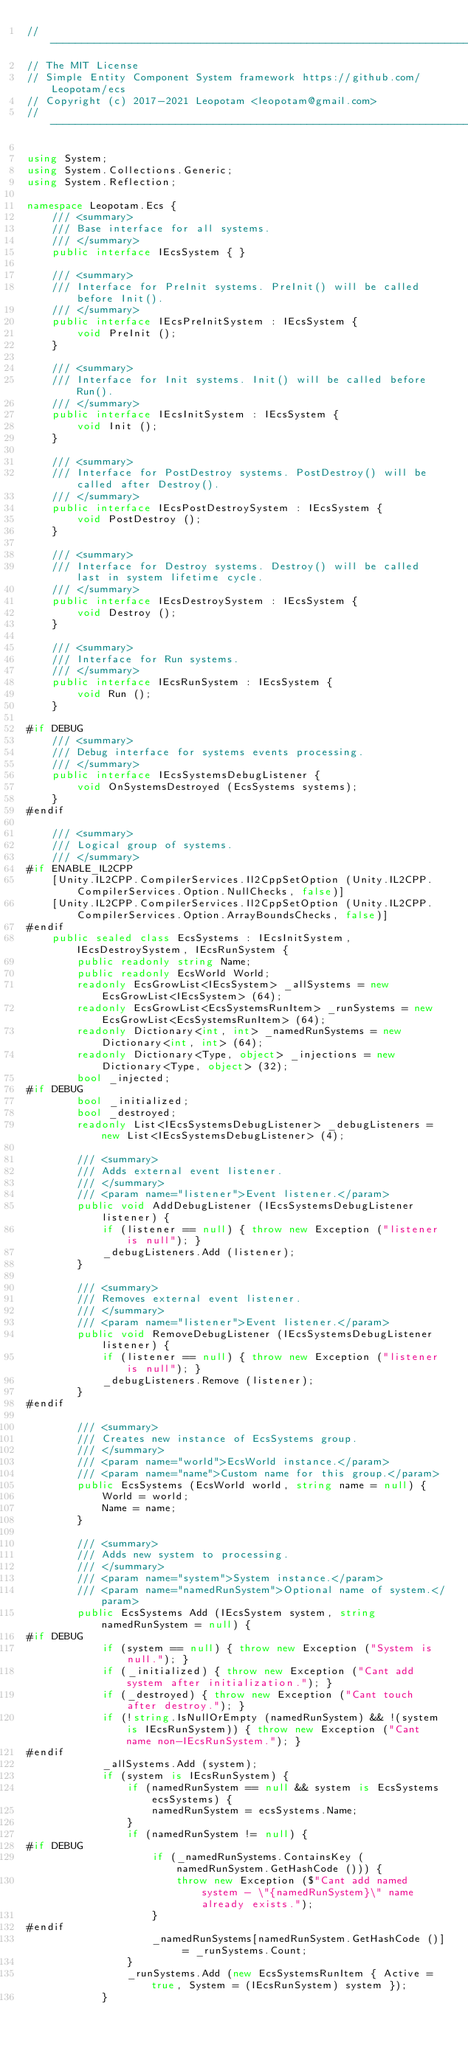Convert code to text. <code><loc_0><loc_0><loc_500><loc_500><_C#_>// ----------------------------------------------------------------------------
// The MIT License
// Simple Entity Component System framework https://github.com/Leopotam/ecs
// Copyright (c) 2017-2021 Leopotam <leopotam@gmail.com>
// ----------------------------------------------------------------------------

using System;
using System.Collections.Generic;
using System.Reflection;

namespace Leopotam.Ecs {
    /// <summary>
    /// Base interface for all systems.
    /// </summary>
    public interface IEcsSystem { }

    /// <summary>
    /// Interface for PreInit systems. PreInit() will be called before Init().
    /// </summary>
    public interface IEcsPreInitSystem : IEcsSystem {
        void PreInit ();
    }

    /// <summary>
    /// Interface for Init systems. Init() will be called before Run().
    /// </summary>
    public interface IEcsInitSystem : IEcsSystem {
        void Init ();
    }

    /// <summary>
    /// Interface for PostDestroy systems. PostDestroy() will be called after Destroy().
    /// </summary>
    public interface IEcsPostDestroySystem : IEcsSystem {
        void PostDestroy ();
    }

    /// <summary>
    /// Interface for Destroy systems. Destroy() will be called last in system lifetime cycle.
    /// </summary>
    public interface IEcsDestroySystem : IEcsSystem {
        void Destroy ();
    }

    /// <summary>
    /// Interface for Run systems.
    /// </summary>
    public interface IEcsRunSystem : IEcsSystem {
        void Run ();
    }

#if DEBUG
    /// <summary>
    /// Debug interface for systems events processing.
    /// </summary>
    public interface IEcsSystemsDebugListener {
        void OnSystemsDestroyed (EcsSystems systems);
    }
#endif

    /// <summary>
    /// Logical group of systems.
    /// </summary>
#if ENABLE_IL2CPP
    [Unity.IL2CPP.CompilerServices.Il2CppSetOption (Unity.IL2CPP.CompilerServices.Option.NullChecks, false)]
    [Unity.IL2CPP.CompilerServices.Il2CppSetOption (Unity.IL2CPP.CompilerServices.Option.ArrayBoundsChecks, false)]
#endif
    public sealed class EcsSystems : IEcsInitSystem, IEcsDestroySystem, IEcsRunSystem {
        public readonly string Name;
        public readonly EcsWorld World;
        readonly EcsGrowList<IEcsSystem> _allSystems = new EcsGrowList<IEcsSystem> (64);
        readonly EcsGrowList<EcsSystemsRunItem> _runSystems = new EcsGrowList<EcsSystemsRunItem> (64);
        readonly Dictionary<int, int> _namedRunSystems = new Dictionary<int, int> (64);
        readonly Dictionary<Type, object> _injections = new Dictionary<Type, object> (32);
        bool _injected;
#if DEBUG
        bool _initialized;
        bool _destroyed;
        readonly List<IEcsSystemsDebugListener> _debugListeners = new List<IEcsSystemsDebugListener> (4);

        /// <summary>
        /// Adds external event listener.
        /// </summary>
        /// <param name="listener">Event listener.</param>
        public void AddDebugListener (IEcsSystemsDebugListener listener) {
            if (listener == null) { throw new Exception ("listener is null"); }
            _debugListeners.Add (listener);
        }

        /// <summary>
        /// Removes external event listener.
        /// </summary>
        /// <param name="listener">Event listener.</param>
        public void RemoveDebugListener (IEcsSystemsDebugListener listener) {
            if (listener == null) { throw new Exception ("listener is null"); }
            _debugListeners.Remove (listener);
        }
#endif

        /// <summary>
        /// Creates new instance of EcsSystems group.
        /// </summary>
        /// <param name="world">EcsWorld instance.</param>
        /// <param name="name">Custom name for this group.</param>
        public EcsSystems (EcsWorld world, string name = null) {
            World = world;
            Name = name;
        }

        /// <summary>
        /// Adds new system to processing.
        /// </summary>
        /// <param name="system">System instance.</param>
        /// <param name="namedRunSystem">Optional name of system.</param>
        public EcsSystems Add (IEcsSystem system, string namedRunSystem = null) {
#if DEBUG
            if (system == null) { throw new Exception ("System is null."); }
            if (_initialized) { throw new Exception ("Cant add system after initialization."); }
            if (_destroyed) { throw new Exception ("Cant touch after destroy."); }
            if (!string.IsNullOrEmpty (namedRunSystem) && !(system is IEcsRunSystem)) { throw new Exception ("Cant name non-IEcsRunSystem."); }
#endif
            _allSystems.Add (system);
            if (system is IEcsRunSystem) {
                if (namedRunSystem == null && system is EcsSystems ecsSystems) {
                    namedRunSystem = ecsSystems.Name;
                }
                if (namedRunSystem != null) {
#if DEBUG
                    if (_namedRunSystems.ContainsKey (namedRunSystem.GetHashCode ())) {
                        throw new Exception ($"Cant add named system - \"{namedRunSystem}\" name already exists.");
                    }
#endif
                    _namedRunSystems[namedRunSystem.GetHashCode ()] = _runSystems.Count;
                }
                _runSystems.Add (new EcsSystemsRunItem { Active = true, System = (IEcsRunSystem) system });
            }</code> 